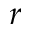<formula> <loc_0><loc_0><loc_500><loc_500>r</formula> 